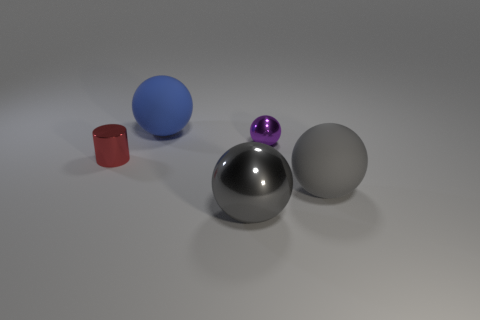Add 2 objects. How many objects exist? 7 Subtract all balls. How many objects are left? 1 Subtract 0 yellow blocks. How many objects are left? 5 Subtract all large green rubber cylinders. Subtract all red cylinders. How many objects are left? 4 Add 5 big gray shiny objects. How many big gray shiny objects are left? 6 Add 4 gray spheres. How many gray spheres exist? 6 